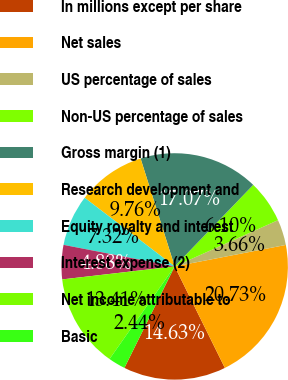Convert chart to OTSL. <chart><loc_0><loc_0><loc_500><loc_500><pie_chart><fcel>In millions except per share<fcel>Net sales<fcel>US percentage of sales<fcel>Non-US percentage of sales<fcel>Gross margin (1)<fcel>Research development and<fcel>Equity royalty and interest<fcel>Interest expense (2)<fcel>Net income attributable to<fcel>Basic<nl><fcel>14.63%<fcel>20.73%<fcel>3.66%<fcel>6.1%<fcel>17.07%<fcel>9.76%<fcel>7.32%<fcel>4.88%<fcel>13.41%<fcel>2.44%<nl></chart> 